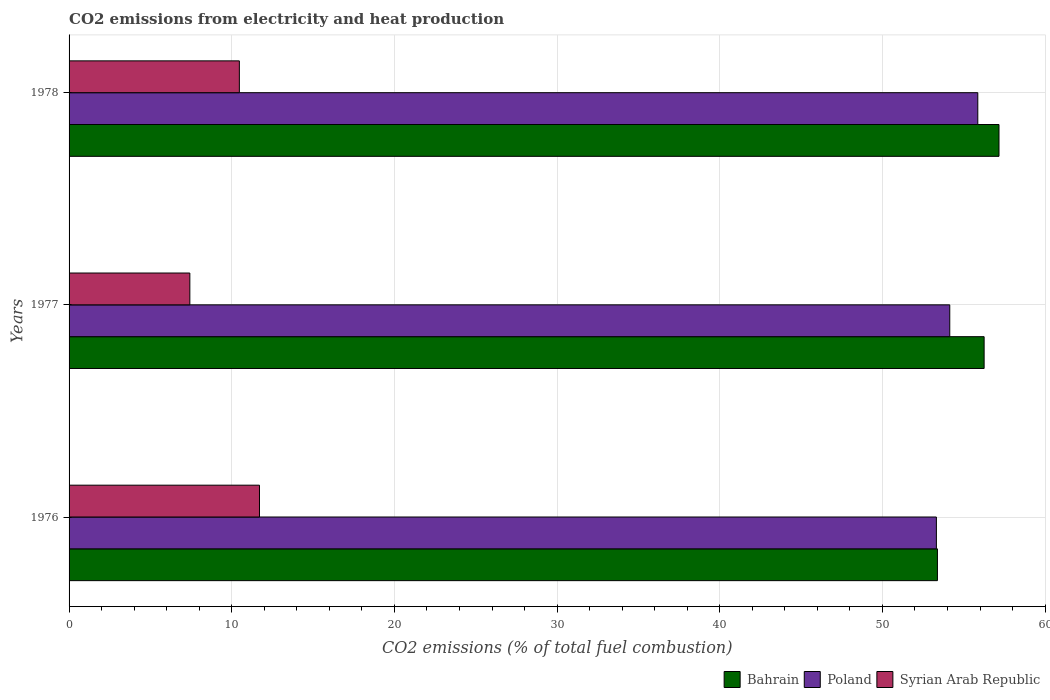How many groups of bars are there?
Your answer should be very brief. 3. Are the number of bars on each tick of the Y-axis equal?
Offer a very short reply. Yes. How many bars are there on the 2nd tick from the top?
Ensure brevity in your answer.  3. What is the label of the 1st group of bars from the top?
Your response must be concise. 1978. In how many cases, is the number of bars for a given year not equal to the number of legend labels?
Provide a short and direct response. 0. What is the amount of CO2 emitted in Bahrain in 1976?
Keep it short and to the point. 53.38. Across all years, what is the maximum amount of CO2 emitted in Poland?
Your response must be concise. 55.86. Across all years, what is the minimum amount of CO2 emitted in Syrian Arab Republic?
Make the answer very short. 7.42. In which year was the amount of CO2 emitted in Bahrain maximum?
Your response must be concise. 1978. In which year was the amount of CO2 emitted in Bahrain minimum?
Offer a terse response. 1976. What is the total amount of CO2 emitted in Bahrain in the graph?
Provide a short and direct response. 166.79. What is the difference between the amount of CO2 emitted in Bahrain in 1976 and that in 1978?
Offer a very short reply. -3.78. What is the difference between the amount of CO2 emitted in Bahrain in 1977 and the amount of CO2 emitted in Poland in 1976?
Keep it short and to the point. 2.93. What is the average amount of CO2 emitted in Poland per year?
Give a very brief answer. 54.44. In the year 1976, what is the difference between the amount of CO2 emitted in Bahrain and amount of CO2 emitted in Poland?
Your answer should be very brief. 0.06. In how many years, is the amount of CO2 emitted in Bahrain greater than 46 %?
Offer a terse response. 3. What is the ratio of the amount of CO2 emitted in Bahrain in 1977 to that in 1978?
Provide a short and direct response. 0.98. What is the difference between the highest and the second highest amount of CO2 emitted in Poland?
Your response must be concise. 1.72. What is the difference between the highest and the lowest amount of CO2 emitted in Syrian Arab Republic?
Offer a very short reply. 4.28. Is the sum of the amount of CO2 emitted in Poland in 1976 and 1977 greater than the maximum amount of CO2 emitted in Syrian Arab Republic across all years?
Your answer should be very brief. Yes. What does the 3rd bar from the top in 1976 represents?
Keep it short and to the point. Bahrain. What does the 1st bar from the bottom in 1976 represents?
Your answer should be very brief. Bahrain. Is it the case that in every year, the sum of the amount of CO2 emitted in Bahrain and amount of CO2 emitted in Syrian Arab Republic is greater than the amount of CO2 emitted in Poland?
Keep it short and to the point. Yes. What is the difference between two consecutive major ticks on the X-axis?
Your answer should be very brief. 10. Are the values on the major ticks of X-axis written in scientific E-notation?
Offer a very short reply. No. Does the graph contain grids?
Make the answer very short. Yes. Where does the legend appear in the graph?
Your response must be concise. Bottom right. How many legend labels are there?
Your answer should be very brief. 3. What is the title of the graph?
Your response must be concise. CO2 emissions from electricity and heat production. Does "Timor-Leste" appear as one of the legend labels in the graph?
Give a very brief answer. No. What is the label or title of the X-axis?
Your answer should be very brief. CO2 emissions (% of total fuel combustion). What is the label or title of the Y-axis?
Offer a terse response. Years. What is the CO2 emissions (% of total fuel combustion) of Bahrain in 1976?
Provide a succinct answer. 53.38. What is the CO2 emissions (% of total fuel combustion) in Poland in 1976?
Offer a very short reply. 53.32. What is the CO2 emissions (% of total fuel combustion) in Syrian Arab Republic in 1976?
Give a very brief answer. 11.71. What is the CO2 emissions (% of total fuel combustion) in Bahrain in 1977?
Provide a succinct answer. 56.25. What is the CO2 emissions (% of total fuel combustion) in Poland in 1977?
Provide a short and direct response. 54.14. What is the CO2 emissions (% of total fuel combustion) in Syrian Arab Republic in 1977?
Make the answer very short. 7.42. What is the CO2 emissions (% of total fuel combustion) in Bahrain in 1978?
Give a very brief answer. 57.16. What is the CO2 emissions (% of total fuel combustion) of Poland in 1978?
Offer a terse response. 55.86. What is the CO2 emissions (% of total fuel combustion) in Syrian Arab Republic in 1978?
Ensure brevity in your answer.  10.47. Across all years, what is the maximum CO2 emissions (% of total fuel combustion) in Bahrain?
Offer a very short reply. 57.16. Across all years, what is the maximum CO2 emissions (% of total fuel combustion) of Poland?
Offer a very short reply. 55.86. Across all years, what is the maximum CO2 emissions (% of total fuel combustion) of Syrian Arab Republic?
Provide a succinct answer. 11.71. Across all years, what is the minimum CO2 emissions (% of total fuel combustion) of Bahrain?
Give a very brief answer. 53.38. Across all years, what is the minimum CO2 emissions (% of total fuel combustion) in Poland?
Your response must be concise. 53.32. Across all years, what is the minimum CO2 emissions (% of total fuel combustion) of Syrian Arab Republic?
Make the answer very short. 7.42. What is the total CO2 emissions (% of total fuel combustion) of Bahrain in the graph?
Your response must be concise. 166.79. What is the total CO2 emissions (% of total fuel combustion) of Poland in the graph?
Your answer should be compact. 163.31. What is the total CO2 emissions (% of total fuel combustion) in Syrian Arab Republic in the graph?
Your answer should be very brief. 29.6. What is the difference between the CO2 emissions (% of total fuel combustion) of Bahrain in 1976 and that in 1977?
Your response must be concise. -2.87. What is the difference between the CO2 emissions (% of total fuel combustion) in Poland in 1976 and that in 1977?
Your response must be concise. -0.82. What is the difference between the CO2 emissions (% of total fuel combustion) of Syrian Arab Republic in 1976 and that in 1977?
Your answer should be very brief. 4.28. What is the difference between the CO2 emissions (% of total fuel combustion) in Bahrain in 1976 and that in 1978?
Keep it short and to the point. -3.78. What is the difference between the CO2 emissions (% of total fuel combustion) of Poland in 1976 and that in 1978?
Make the answer very short. -2.55. What is the difference between the CO2 emissions (% of total fuel combustion) of Syrian Arab Republic in 1976 and that in 1978?
Ensure brevity in your answer.  1.24. What is the difference between the CO2 emissions (% of total fuel combustion) of Bahrain in 1977 and that in 1978?
Your response must be concise. -0.91. What is the difference between the CO2 emissions (% of total fuel combustion) of Poland in 1977 and that in 1978?
Your answer should be very brief. -1.72. What is the difference between the CO2 emissions (% of total fuel combustion) in Syrian Arab Republic in 1977 and that in 1978?
Your answer should be compact. -3.04. What is the difference between the CO2 emissions (% of total fuel combustion) in Bahrain in 1976 and the CO2 emissions (% of total fuel combustion) in Poland in 1977?
Ensure brevity in your answer.  -0.76. What is the difference between the CO2 emissions (% of total fuel combustion) of Bahrain in 1976 and the CO2 emissions (% of total fuel combustion) of Syrian Arab Republic in 1977?
Your answer should be compact. 45.96. What is the difference between the CO2 emissions (% of total fuel combustion) of Poland in 1976 and the CO2 emissions (% of total fuel combustion) of Syrian Arab Republic in 1977?
Make the answer very short. 45.89. What is the difference between the CO2 emissions (% of total fuel combustion) in Bahrain in 1976 and the CO2 emissions (% of total fuel combustion) in Poland in 1978?
Your response must be concise. -2.48. What is the difference between the CO2 emissions (% of total fuel combustion) of Bahrain in 1976 and the CO2 emissions (% of total fuel combustion) of Syrian Arab Republic in 1978?
Provide a short and direct response. 42.91. What is the difference between the CO2 emissions (% of total fuel combustion) in Poland in 1976 and the CO2 emissions (% of total fuel combustion) in Syrian Arab Republic in 1978?
Provide a short and direct response. 42.85. What is the difference between the CO2 emissions (% of total fuel combustion) in Bahrain in 1977 and the CO2 emissions (% of total fuel combustion) in Poland in 1978?
Offer a terse response. 0.39. What is the difference between the CO2 emissions (% of total fuel combustion) in Bahrain in 1977 and the CO2 emissions (% of total fuel combustion) in Syrian Arab Republic in 1978?
Provide a succinct answer. 45.78. What is the difference between the CO2 emissions (% of total fuel combustion) of Poland in 1977 and the CO2 emissions (% of total fuel combustion) of Syrian Arab Republic in 1978?
Offer a terse response. 43.67. What is the average CO2 emissions (% of total fuel combustion) in Bahrain per year?
Provide a succinct answer. 55.6. What is the average CO2 emissions (% of total fuel combustion) of Poland per year?
Ensure brevity in your answer.  54.44. What is the average CO2 emissions (% of total fuel combustion) of Syrian Arab Republic per year?
Offer a terse response. 9.87. In the year 1976, what is the difference between the CO2 emissions (% of total fuel combustion) of Bahrain and CO2 emissions (% of total fuel combustion) of Poland?
Provide a short and direct response. 0.06. In the year 1976, what is the difference between the CO2 emissions (% of total fuel combustion) in Bahrain and CO2 emissions (% of total fuel combustion) in Syrian Arab Republic?
Provide a short and direct response. 41.67. In the year 1976, what is the difference between the CO2 emissions (% of total fuel combustion) of Poland and CO2 emissions (% of total fuel combustion) of Syrian Arab Republic?
Ensure brevity in your answer.  41.61. In the year 1977, what is the difference between the CO2 emissions (% of total fuel combustion) in Bahrain and CO2 emissions (% of total fuel combustion) in Poland?
Offer a terse response. 2.11. In the year 1977, what is the difference between the CO2 emissions (% of total fuel combustion) of Bahrain and CO2 emissions (% of total fuel combustion) of Syrian Arab Republic?
Keep it short and to the point. 48.83. In the year 1977, what is the difference between the CO2 emissions (% of total fuel combustion) of Poland and CO2 emissions (% of total fuel combustion) of Syrian Arab Republic?
Provide a succinct answer. 46.71. In the year 1978, what is the difference between the CO2 emissions (% of total fuel combustion) of Bahrain and CO2 emissions (% of total fuel combustion) of Poland?
Provide a succinct answer. 1.3. In the year 1978, what is the difference between the CO2 emissions (% of total fuel combustion) in Bahrain and CO2 emissions (% of total fuel combustion) in Syrian Arab Republic?
Your answer should be compact. 46.7. In the year 1978, what is the difference between the CO2 emissions (% of total fuel combustion) of Poland and CO2 emissions (% of total fuel combustion) of Syrian Arab Republic?
Offer a terse response. 45.39. What is the ratio of the CO2 emissions (% of total fuel combustion) in Bahrain in 1976 to that in 1977?
Offer a terse response. 0.95. What is the ratio of the CO2 emissions (% of total fuel combustion) in Poland in 1976 to that in 1977?
Ensure brevity in your answer.  0.98. What is the ratio of the CO2 emissions (% of total fuel combustion) of Syrian Arab Republic in 1976 to that in 1977?
Offer a terse response. 1.58. What is the ratio of the CO2 emissions (% of total fuel combustion) of Bahrain in 1976 to that in 1978?
Give a very brief answer. 0.93. What is the ratio of the CO2 emissions (% of total fuel combustion) of Poland in 1976 to that in 1978?
Provide a succinct answer. 0.95. What is the ratio of the CO2 emissions (% of total fuel combustion) in Syrian Arab Republic in 1976 to that in 1978?
Provide a short and direct response. 1.12. What is the ratio of the CO2 emissions (% of total fuel combustion) in Bahrain in 1977 to that in 1978?
Make the answer very short. 0.98. What is the ratio of the CO2 emissions (% of total fuel combustion) of Poland in 1977 to that in 1978?
Keep it short and to the point. 0.97. What is the ratio of the CO2 emissions (% of total fuel combustion) of Syrian Arab Republic in 1977 to that in 1978?
Provide a short and direct response. 0.71. What is the difference between the highest and the second highest CO2 emissions (% of total fuel combustion) in Bahrain?
Provide a short and direct response. 0.91. What is the difference between the highest and the second highest CO2 emissions (% of total fuel combustion) of Poland?
Your answer should be compact. 1.72. What is the difference between the highest and the second highest CO2 emissions (% of total fuel combustion) of Syrian Arab Republic?
Offer a very short reply. 1.24. What is the difference between the highest and the lowest CO2 emissions (% of total fuel combustion) of Bahrain?
Make the answer very short. 3.78. What is the difference between the highest and the lowest CO2 emissions (% of total fuel combustion) in Poland?
Provide a short and direct response. 2.55. What is the difference between the highest and the lowest CO2 emissions (% of total fuel combustion) of Syrian Arab Republic?
Offer a very short reply. 4.28. 